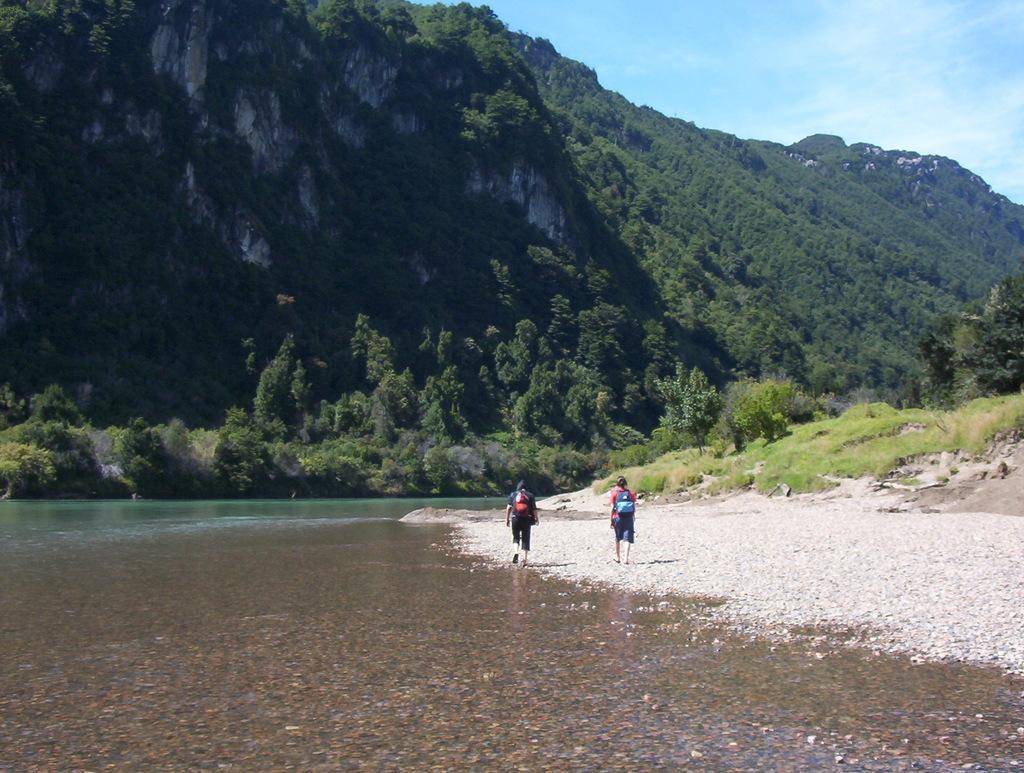Can you describe this image briefly? In this image i can see two persons walking, at the left i can see a water,at the front i can see few trees at the top there is a sky. 